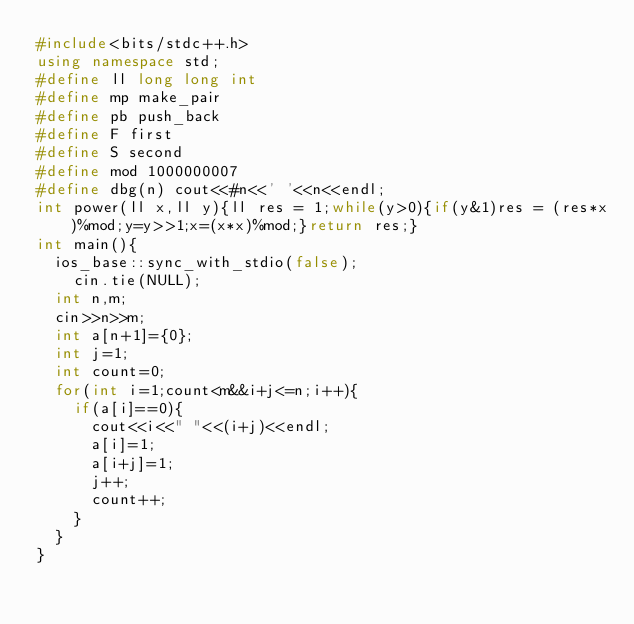Convert code to text. <code><loc_0><loc_0><loc_500><loc_500><_C++_>#include<bits/stdc++.h>
using namespace std;
#define ll long long int
#define mp make_pair
#define pb push_back
#define F first
#define S second
#define mod 1000000007
#define dbg(n) cout<<#n<<' '<<n<<endl;
int power(ll x,ll y){ll res = 1;while(y>0){if(y&1)res = (res*x)%mod;y=y>>1;x=(x*x)%mod;}return res;}
int main(){
	ios_base::sync_with_stdio(false);
    cin.tie(NULL);
	int n,m;
	cin>>n>>m;
	int a[n+1]={0};
	int j=1;
	int count=0;
	for(int i=1;count<m&&i+j<=n;i++){
		if(a[i]==0){
			cout<<i<<" "<<(i+j)<<endl;
			a[i]=1;
			a[i+j]=1;
			j++;
			count++;
		}
	}
}
</code> 